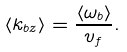<formula> <loc_0><loc_0><loc_500><loc_500>\langle k _ { b z } \rangle = \frac { \langle \omega _ { b } \rangle } { v _ { f } } .</formula> 